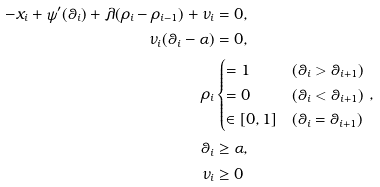<formula> <loc_0><loc_0><loc_500><loc_500>- x _ { i } + \psi ^ { \prime } ( \theta _ { i } ) + \lambda ( \rho _ { i } - \rho _ { i - 1 } ) + \nu _ { i } & = 0 , \\ \nu _ { i } ( \theta _ { i } - \alpha ) & = 0 , \\ \rho _ { i } & \begin{cases} = 1 & ( \theta _ { i } > \theta _ { i + 1 } ) \\ = 0 & ( \theta _ { i } < \theta _ { i + 1 } ) \\ \in [ 0 , 1 ] & ( \theta _ { i } = \theta _ { i + 1 } ) \end{cases} , \\ \theta _ { i } & \geq \alpha , \\ \nu _ { i } & \geq 0</formula> 